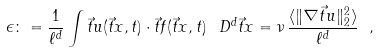<formula> <loc_0><loc_0><loc_500><loc_500>\epsilon \colon = \frac { 1 } { \ell ^ { d } } \int \vec { t } u ( \vec { t } x , t ) \cdot \vec { t } f ( \vec { t } x , t ) \, \ D ^ { d } \vec { t } x = \nu \, \frac { \langle \| \nabla \vec { t } u \| _ { 2 } ^ { 2 } \rangle } { \ell ^ { d } } \ ,</formula> 